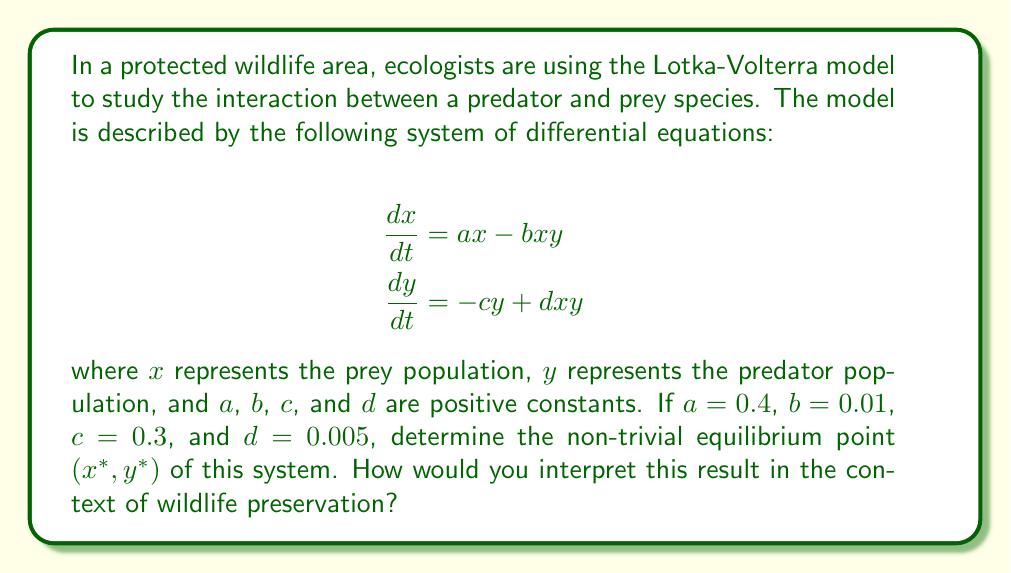Could you help me with this problem? To find the non-trivial equilibrium point, we need to set both equations equal to zero and solve for $x$ and $y$:

1) Set $\frac{dx}{dt} = 0$ and $\frac{dy}{dt} = 0$:

   $$\begin{align}
   0 &= ax - bxy \\
   0 &= -cy + dxy
   \end{align}$$

2) From the first equation:
   
   $$ax - bxy = 0$$
   $$x(a - by) = 0$$

   For a non-trivial solution, $x \neq 0$, so:
   
   $$a - by = 0$$
   $$y = \frac{a}{b}$$

3) From the second equation:
   
   $$-cy + dxy = 0$$
   $$y(-c + dx) = 0$$

   For a non-trivial solution, $y \neq 0$, so:
   
   $$-c + dx = 0$$
   $$x = \frac{c}{d}$$

4) Substitute the given values:

   $$x^* = \frac{c}{d} = \frac{0.3}{0.005} = 60$$
   $$y^* = \frac{a}{b} = \frac{0.4}{0.01} = 40$$

5) Therefore, the non-trivial equilibrium point is $(x^*, y^*) = (60, 40)$.

Interpretation: This equilibrium point represents a stable coexistence of predator and prey populations. In the context of wildlife preservation, it suggests that if the protected area can maintain approximately 60 prey animals for every 40 predators, the ecosystem should remain in balance. This information can guide conservation efforts, such as habitat management or population control measures, to maintain this optimal ratio and ensure long-term stability of both species.
Answer: $(60, 40)$ 